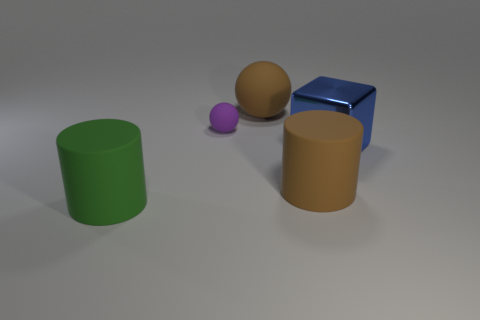What is the size of the purple object behind the brown object in front of the purple rubber thing?
Offer a terse response. Small. Is there a small matte thing that has the same shape as the shiny thing?
Provide a succinct answer. No. Do the brown rubber thing that is on the right side of the brown rubber sphere and the rubber ball in front of the brown sphere have the same size?
Offer a terse response. No. Are there fewer large matte things that are right of the big blue metal object than large green matte objects left of the big green cylinder?
Give a very brief answer. No. There is a cylinder that is the same color as the large sphere; what material is it?
Offer a very short reply. Rubber. What is the color of the large cylinder to the right of the big green cylinder?
Ensure brevity in your answer.  Brown. Is the tiny thing the same color as the big metallic cube?
Make the answer very short. No. How many metallic cubes are behind the big brown matte object on the left side of the big brown matte object in front of the big block?
Your response must be concise. 0. The brown matte sphere has what size?
Provide a short and direct response. Large. There is a brown cylinder that is the same size as the blue object; what material is it?
Your response must be concise. Rubber. 